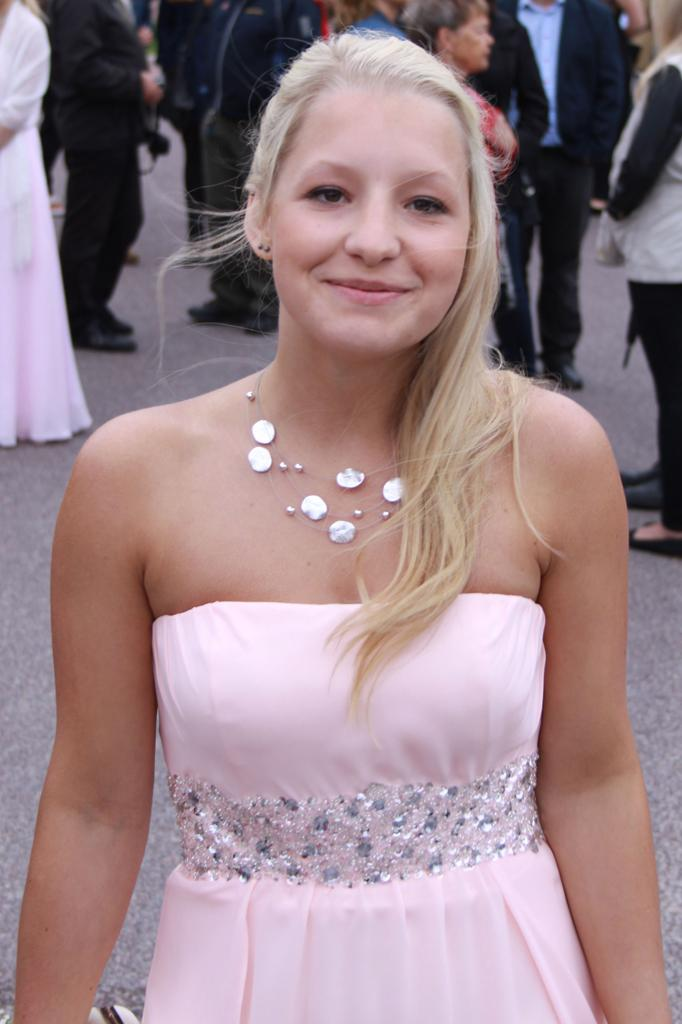Where was the image taken? The image is taken outdoors. What can be seen in the background of the image? There are people standing on the road in the background. What is happening in the middle of the image? A woman is standing on the road in the middle of the image. How is the woman's expression in the image? The woman has a smiling face. What type of seed is the woman holding in her hand in the image? There is no seed present in the image; the woman is not holding anything in her hand. 